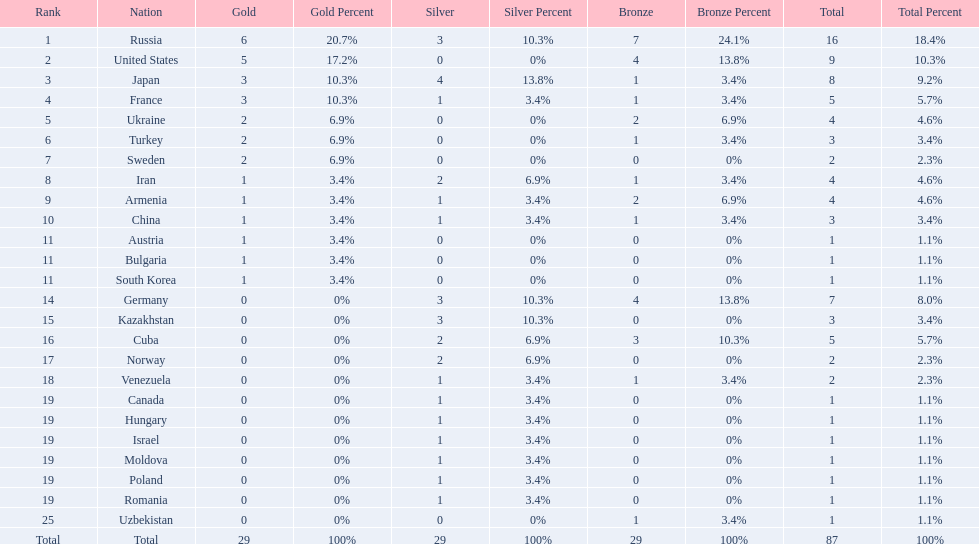How many gold medals did the united states win? 5. Who won more than 5 gold medals? Russia. 